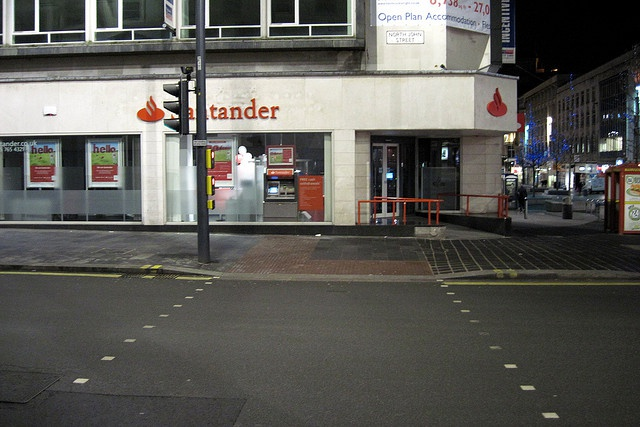Describe the objects in this image and their specific colors. I can see traffic light in black, gray, darkgray, and ivory tones, car in black, gray, and purple tones, car in black, gray, and blue tones, car in black, gray, and darkblue tones, and people in black, gray, darkblue, and purple tones in this image. 